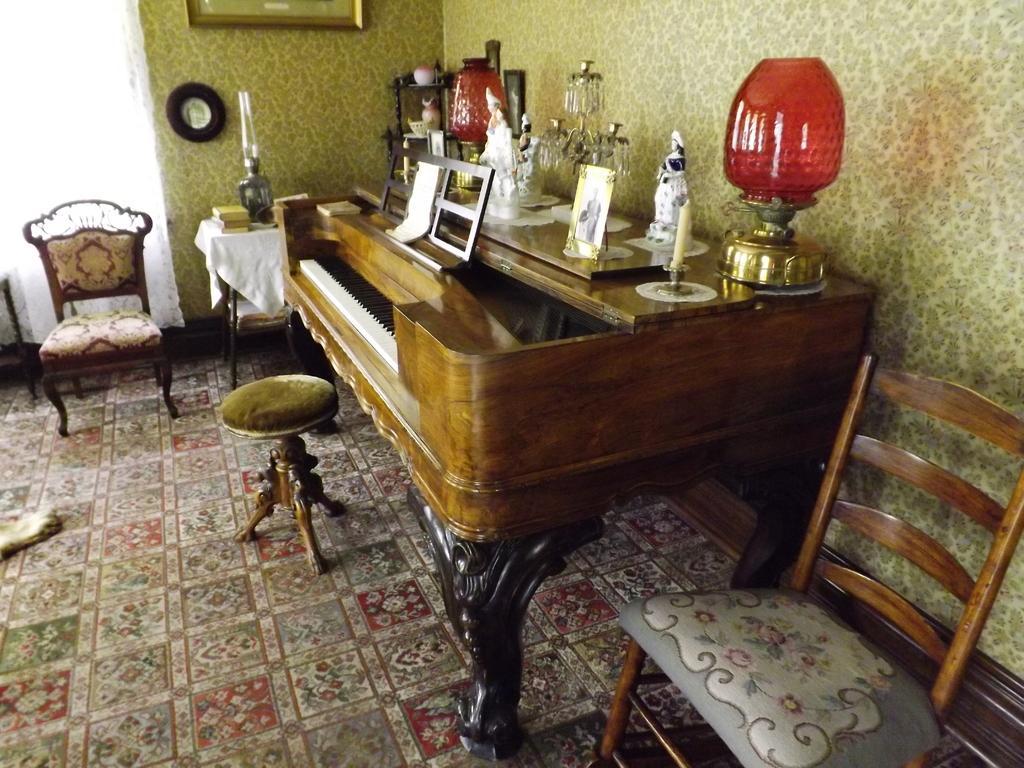Could you give a brief overview of what you see in this image? In this image in the center there is one piano and on that piano there is one photo frame, candle, lamps and one chandelier is there and on the background there is a wall. On that wall there is one photo frame beside the piano there is one chair and on the bottom of the right corner there is another chair. 